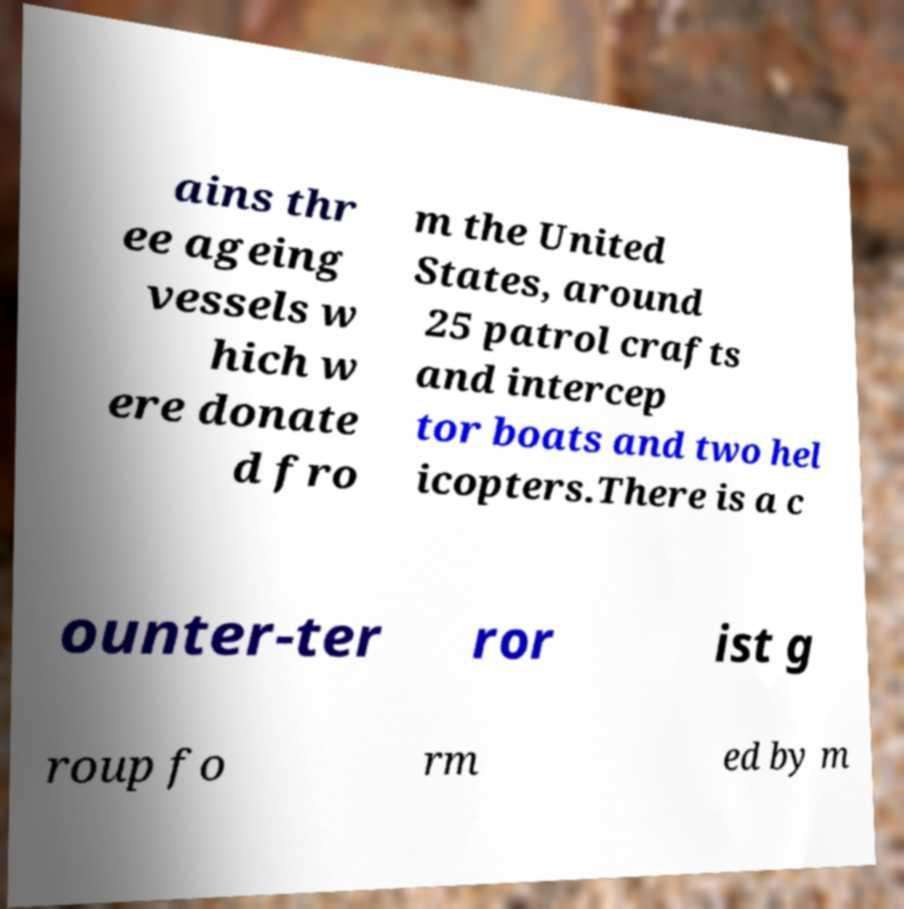What messages or text are displayed in this image? I need them in a readable, typed format. ains thr ee ageing vessels w hich w ere donate d fro m the United States, around 25 patrol crafts and intercep tor boats and two hel icopters.There is a c ounter-ter ror ist g roup fo rm ed by m 